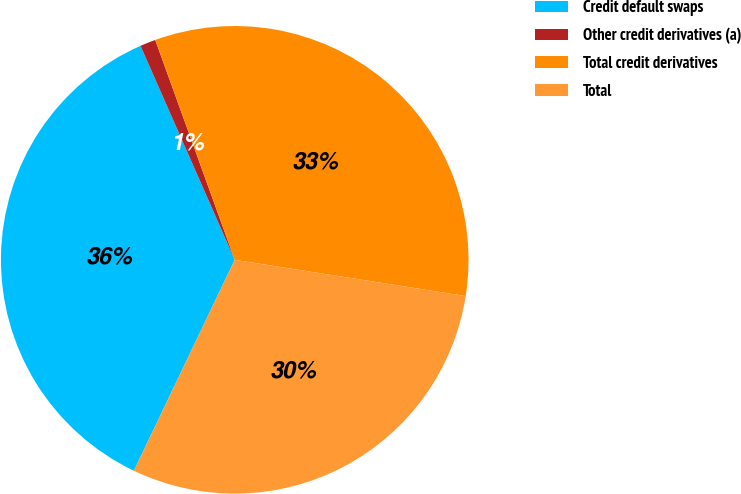Convert chart to OTSL. <chart><loc_0><loc_0><loc_500><loc_500><pie_chart><fcel>Credit default swaps<fcel>Other credit derivatives (a)<fcel>Total credit derivatives<fcel>Total<nl><fcel>36.3%<fcel>1.08%<fcel>33.0%<fcel>29.62%<nl></chart> 